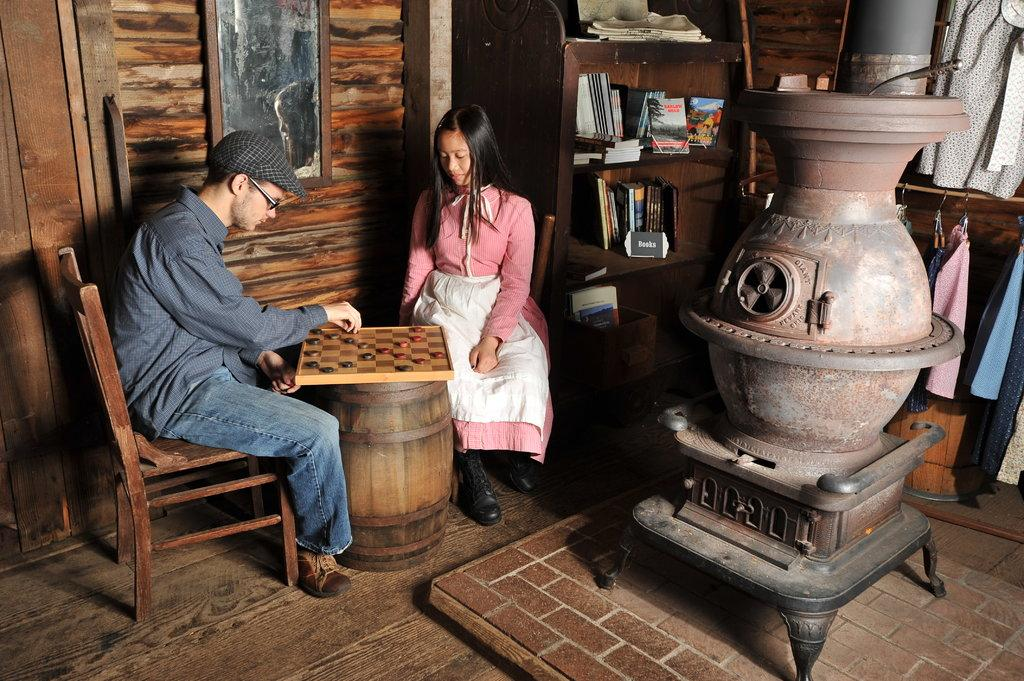How many people are present in the image? There are two people, a man and a woman, present in the image. What are the man and woman doing in the image? The man and woman are playing chess in the image. What can be seen on the shelf in the image? There are books on the shelf in the image. What is the large object in the image? There is a big pot in the image. What is hanging on the wall in the image? There is a photo frame on the wall in the image. What is the degree of the circle in the image? There is no circle present in the image, so it is not possible to determine its degree. 